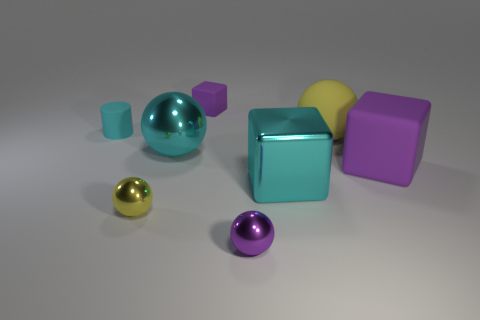What is the color of the tiny rubber object that is on the left side of the small purple block?
Offer a terse response. Cyan. There is a purple rubber cube that is in front of the small cyan rubber object; is there a matte thing left of it?
Your response must be concise. Yes. There is a tiny yellow object; is it the same shape as the big cyan metallic thing that is to the left of the purple sphere?
Your answer should be compact. Yes. There is a ball that is both left of the tiny purple matte block and behind the big purple thing; what is its size?
Keep it short and to the point. Large. Are there any tiny balls that have the same material as the cyan block?
Provide a succinct answer. Yes. There is a sphere that is the same color as the matte cylinder; what is its size?
Ensure brevity in your answer.  Large. What is the material of the cyan thing that is left of the small yellow object that is on the right side of the cyan rubber object?
Provide a succinct answer. Rubber. How many big rubber things have the same color as the tiny cylinder?
Your answer should be compact. 0. What is the size of the cube that is the same material as the small purple ball?
Keep it short and to the point. Large. What shape is the small purple thing behind the big yellow ball?
Keep it short and to the point. Cube. 